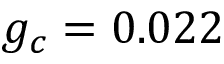Convert formula to latex. <formula><loc_0><loc_0><loc_500><loc_500>g _ { c } = 0 . 0 2 2</formula> 